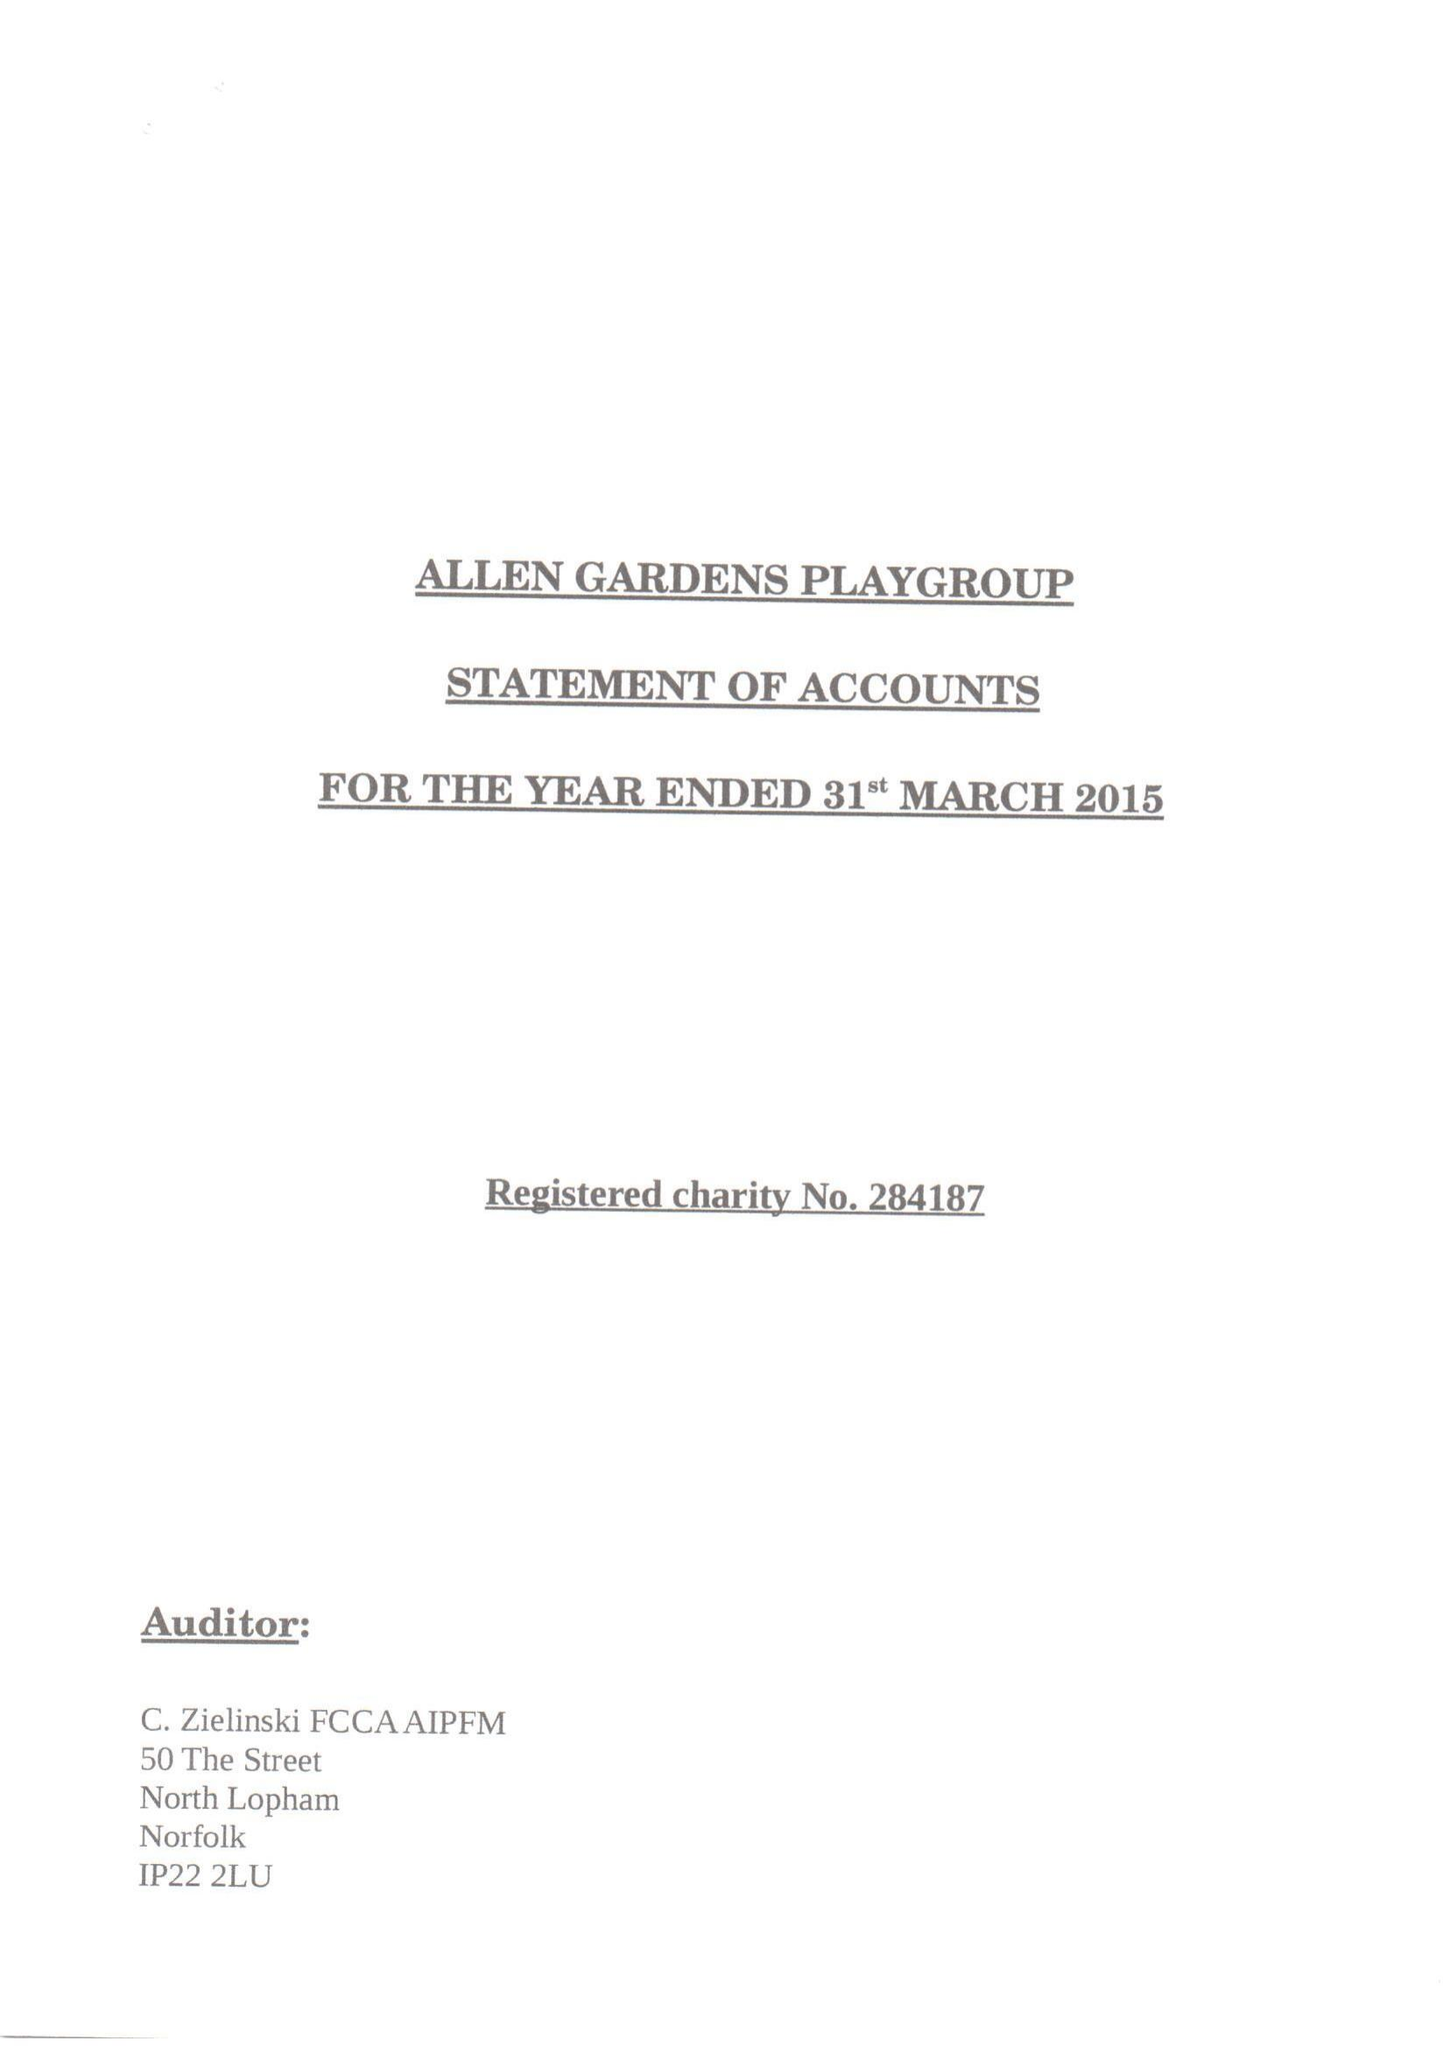What is the value for the charity_number?
Answer the question using a single word or phrase. 284187 